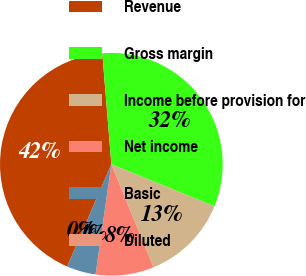<chart> <loc_0><loc_0><loc_500><loc_500><pie_chart><fcel>Revenue<fcel>Gross margin<fcel>Income before provision for<fcel>Net income<fcel>Basic<fcel>Diluted<nl><fcel>42.22%<fcel>32.46%<fcel>12.66%<fcel>8.44%<fcel>4.22%<fcel>0.0%<nl></chart> 